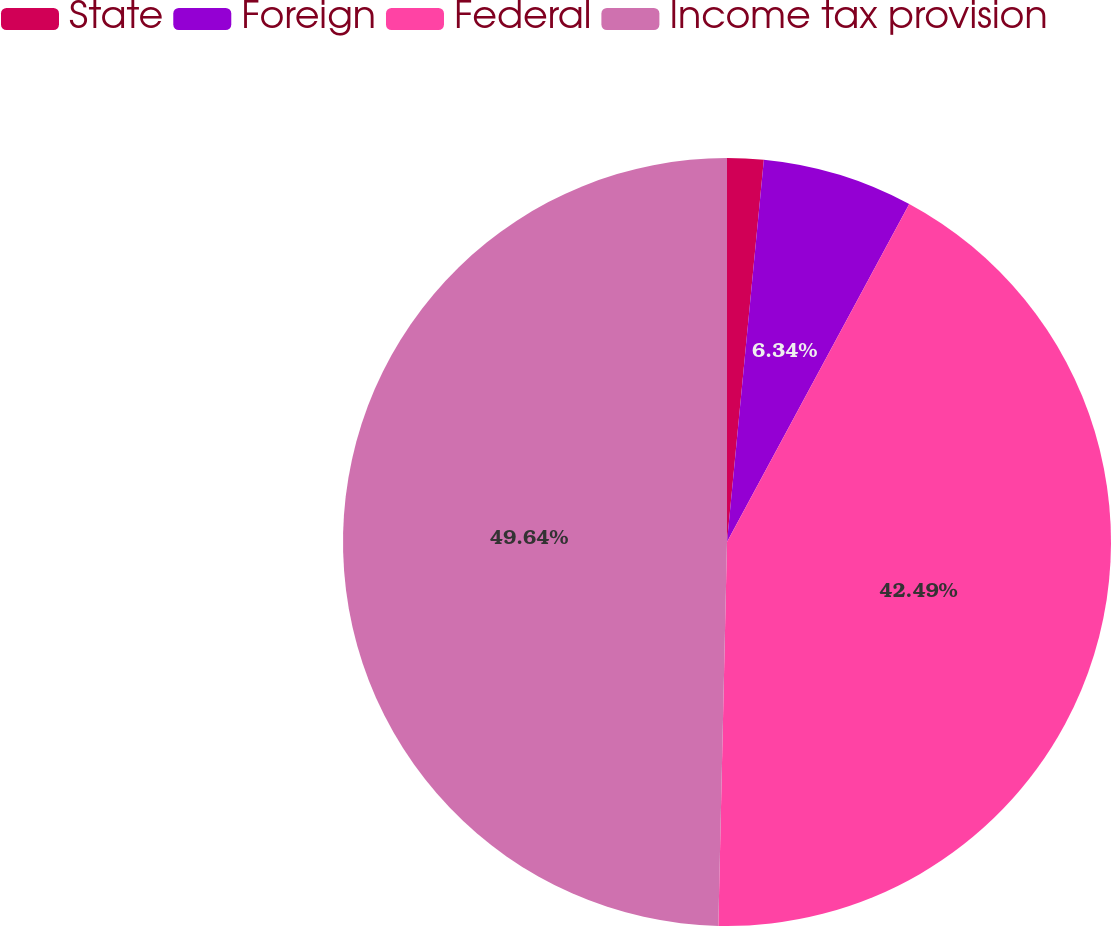<chart> <loc_0><loc_0><loc_500><loc_500><pie_chart><fcel>State<fcel>Foreign<fcel>Federal<fcel>Income tax provision<nl><fcel>1.53%<fcel>6.34%<fcel>42.49%<fcel>49.64%<nl></chart> 